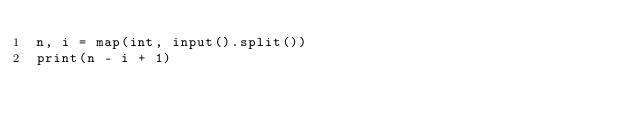Convert code to text. <code><loc_0><loc_0><loc_500><loc_500><_Python_>n, i = map(int, input().split())
print(n - i + 1)</code> 